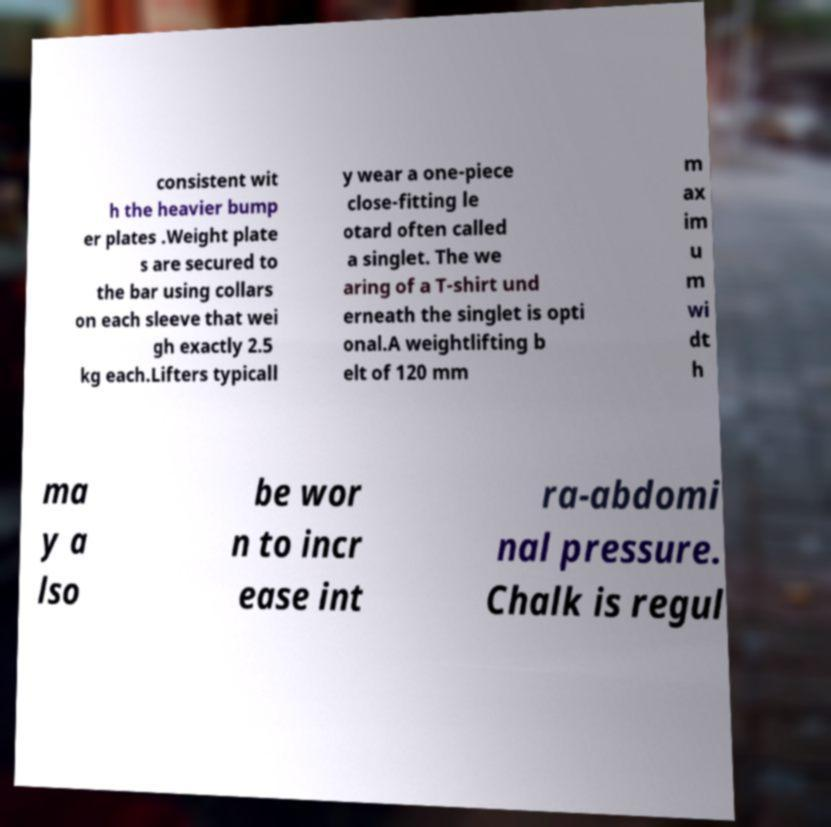Can you read and provide the text displayed in the image?This photo seems to have some interesting text. Can you extract and type it out for me? consistent wit h the heavier bump er plates .Weight plate s are secured to the bar using collars on each sleeve that wei gh exactly 2.5 kg each.Lifters typicall y wear a one-piece close-fitting le otard often called a singlet. The we aring of a T-shirt und erneath the singlet is opti onal.A weightlifting b elt of 120 mm m ax im u m wi dt h ma y a lso be wor n to incr ease int ra-abdomi nal pressure. Chalk is regul 